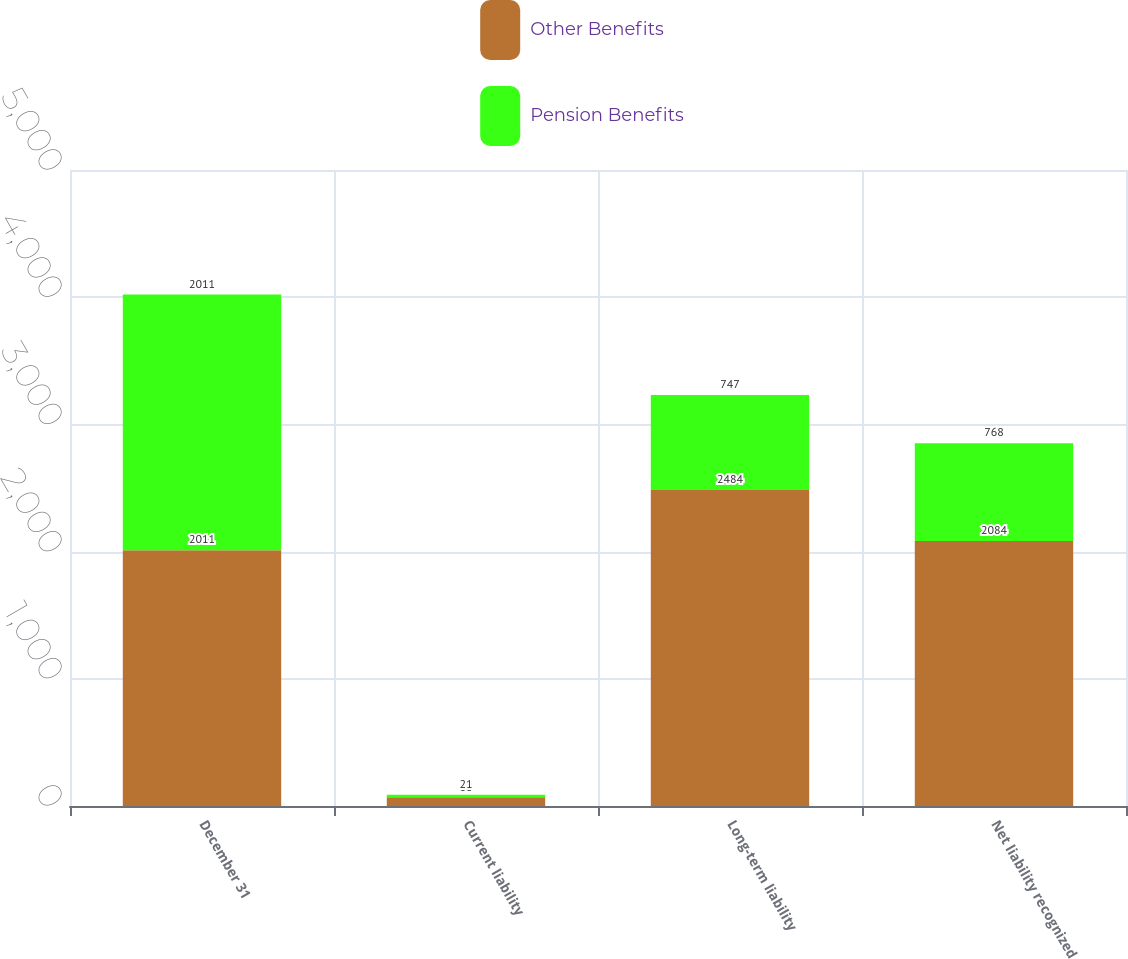<chart> <loc_0><loc_0><loc_500><loc_500><stacked_bar_chart><ecel><fcel>December 31<fcel>Current liability<fcel>Long-term liability<fcel>Net liability recognized<nl><fcel>Other Benefits<fcel>2011<fcel>68<fcel>2484<fcel>2084<nl><fcel>Pension Benefits<fcel>2011<fcel>21<fcel>747<fcel>768<nl></chart> 